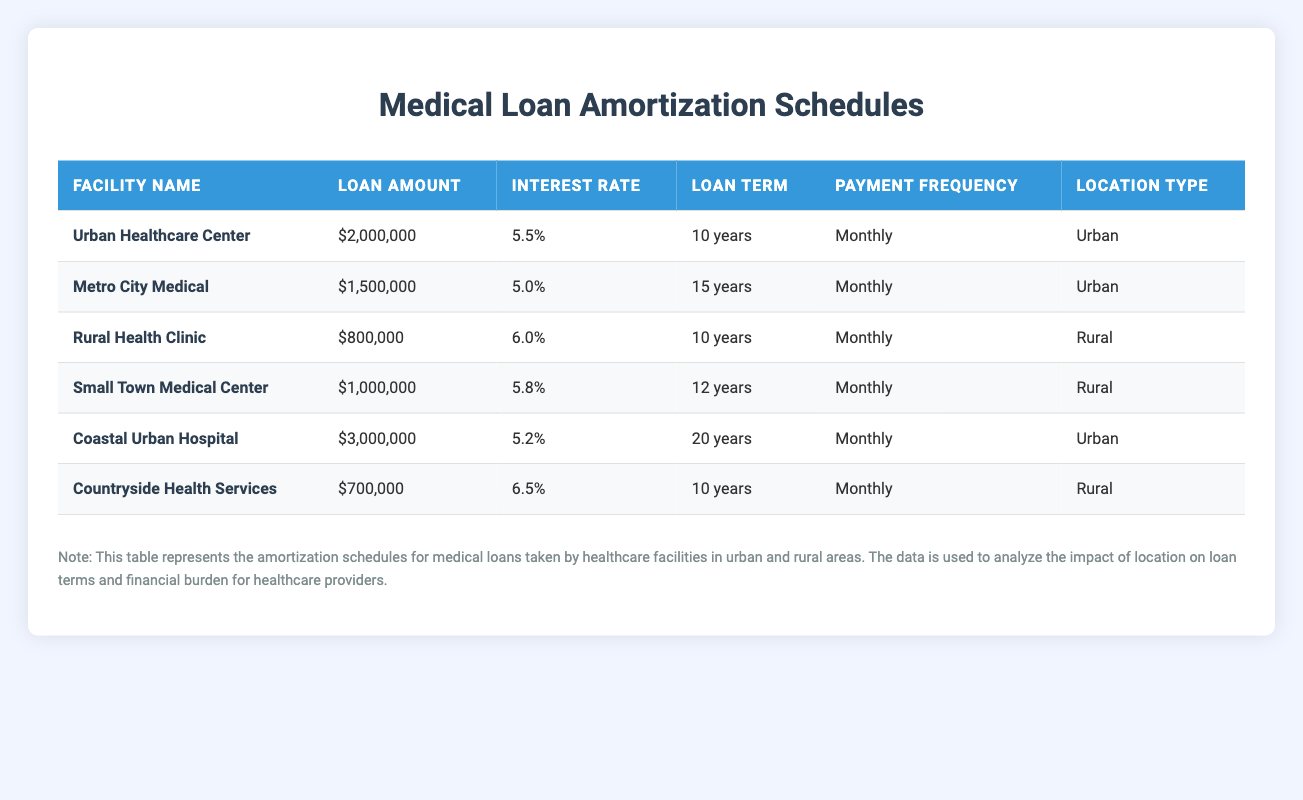What is the loan amount for the Coastal Urban Hospital? The loan amount is listed directly in the row for Coastal Urban Hospital in the table. It shows $3,000,000.
Answer: $3,000,000 How many facilities in the table have an interest rate lower than 6%? From the table, we can see that the rates for Metro City Medical (5.0%) and Coastal Urban Hospital (5.2%) are below 6%. This gives us a total of two facilities.
Answer: 2 What is the total loan amount for rural healthcare facilities? To find the total loan amount for rural facilities, we add the amounts: $800,000 (Rural Health Clinic) + $1,000,000 (Small Town Medical Center) + $700,000 (Countryside Health Services) = $2,500,000.
Answer: $2,500,000 Is the interest rate for Small Town Medical Center higher than that of Urban Healthcare Center? The table shows that Small Town Medical Center has an interest rate of 5.8% while Urban Healthcare Center has an interest rate of 5.5%. Since 5.8% is greater than 5.5%, the statement is true.
Answer: Yes What is the average loan term for urban healthcare facilities? To find the average loan term, we will sum the terms for the urban facilities: 10 years (Urban Healthcare Center) + 15 years (Metro City Medical) + 20 years (Coastal Urban Hospital) = 45 years. There are three urban facilities, so we divide 45 by 3 to get an average of 15 years.
Answer: 15 years Which rural facility has the highest loan amount, and what is that amount? By checking the loan amounts for rural facilities, we see that the Rural Health Clinic has $800,000, Small Town Medical Center has $1,000,000, and Countryside Health Services has $700,000. The highest amount is from Small Town Medical Center, which is $1,000,000.
Answer: Small Town Medical Center, $1,000,000 What is the difference in loan amount between the largest urban facility and the largest rural facility? The largest urban facility is Coastal Urban Hospital with a loan of $3,000,000, while the largest rural facility is Small Town Medical Center with a loan of $1,000,000. The difference is calculated as $3,000,000 - $1,000,000 = $2,000,000.
Answer: $2,000,000 How many urban facilities have a loan term greater than 15 years? Looking at the urban facilities, only Coastal Urban Hospital has a loan term of 20 years, while the other two facilities have terms of 10 and 15 years, respectively. Thus, there is only one urban facility with a term greater than 15 years.
Answer: 1 